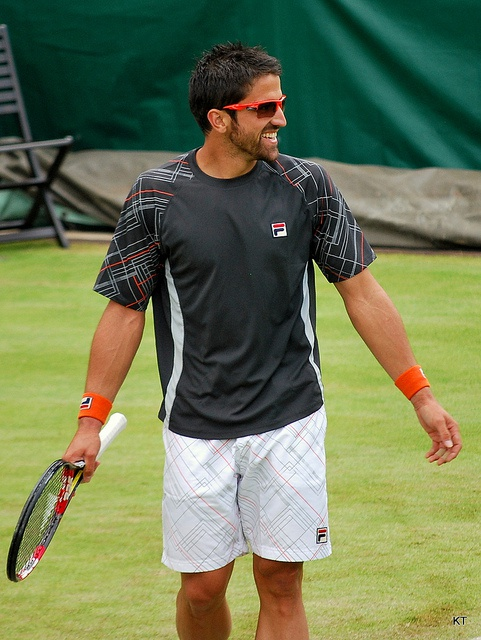Describe the objects in this image and their specific colors. I can see people in darkgreen, black, lightgray, brown, and gray tones, chair in darkgreen, gray, black, and purple tones, and tennis racket in darkgreen, black, olive, and gray tones in this image. 